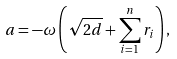<formula> <loc_0><loc_0><loc_500><loc_500>a = - \omega \left ( \sqrt { 2 d } + \sum _ { i = 1 } ^ { n } r _ { i } \right ) ,</formula> 